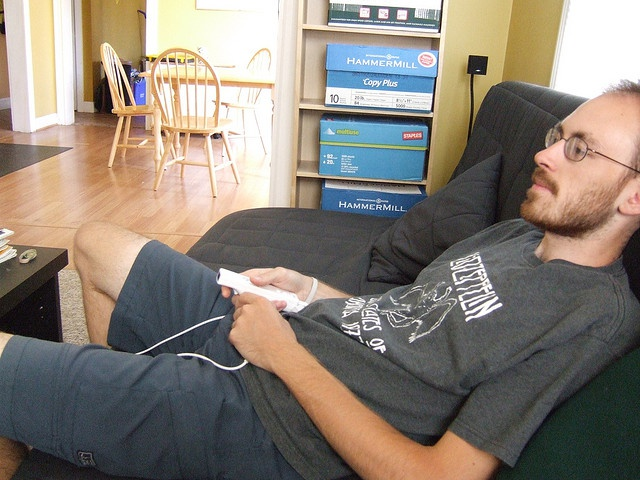Describe the objects in this image and their specific colors. I can see people in olive, gray, black, tan, and darkblue tones, couch in olive, black, and gray tones, chair in olive, ivory, and tan tones, chair in olive, tan, and ivory tones, and dining table in olive, ivory, and tan tones in this image. 